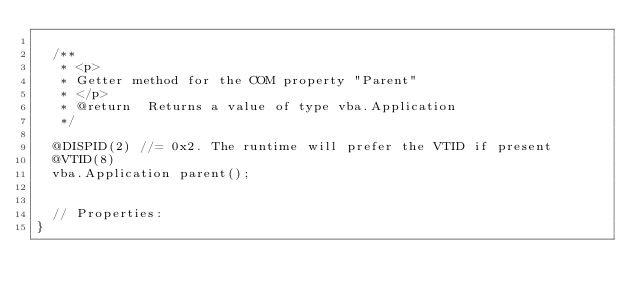Convert code to text. <code><loc_0><loc_0><loc_500><loc_500><_Java_>
  /**
   * <p>
   * Getter method for the COM property "Parent"
   * </p>
   * @return  Returns a value of type vba.Application
   */

  @DISPID(2) //= 0x2. The runtime will prefer the VTID if present
  @VTID(8)
  vba.Application parent();


  // Properties:
}
</code> 